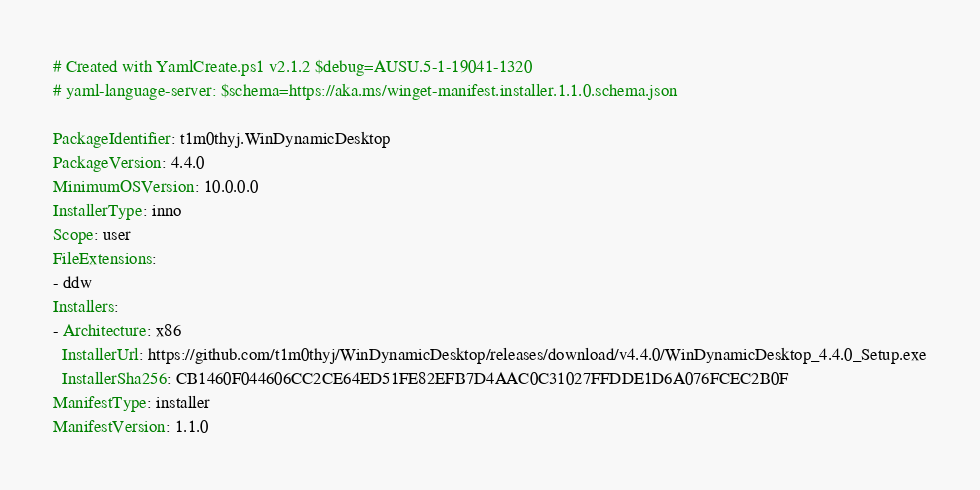Convert code to text. <code><loc_0><loc_0><loc_500><loc_500><_YAML_># Created with YamlCreate.ps1 v2.1.2 $debug=AUSU.5-1-19041-1320
# yaml-language-server: $schema=https://aka.ms/winget-manifest.installer.1.1.0.schema.json

PackageIdentifier: t1m0thyj.WinDynamicDesktop
PackageVersion: 4.4.0
MinimumOSVersion: 10.0.0.0
InstallerType: inno
Scope: user
FileExtensions:
- ddw
Installers:
- Architecture: x86
  InstallerUrl: https://github.com/t1m0thyj/WinDynamicDesktop/releases/download/v4.4.0/WinDynamicDesktop_4.4.0_Setup.exe
  InstallerSha256: CB1460F044606CC2CE64ED51FE82EFB7D4AAC0C31027FFDDE1D6A076FCEC2B0F
ManifestType: installer
ManifestVersion: 1.1.0
</code> 